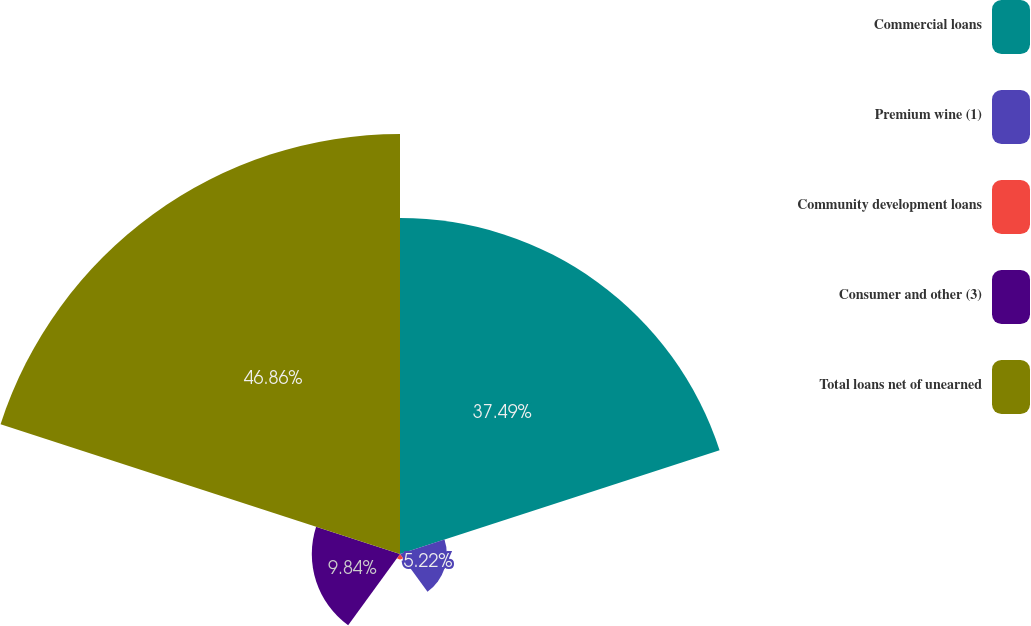Convert chart to OTSL. <chart><loc_0><loc_0><loc_500><loc_500><pie_chart><fcel>Commercial loans<fcel>Premium wine (1)<fcel>Community development loans<fcel>Consumer and other (3)<fcel>Total loans net of unearned<nl><fcel>37.49%<fcel>5.22%<fcel>0.59%<fcel>9.84%<fcel>46.86%<nl></chart> 